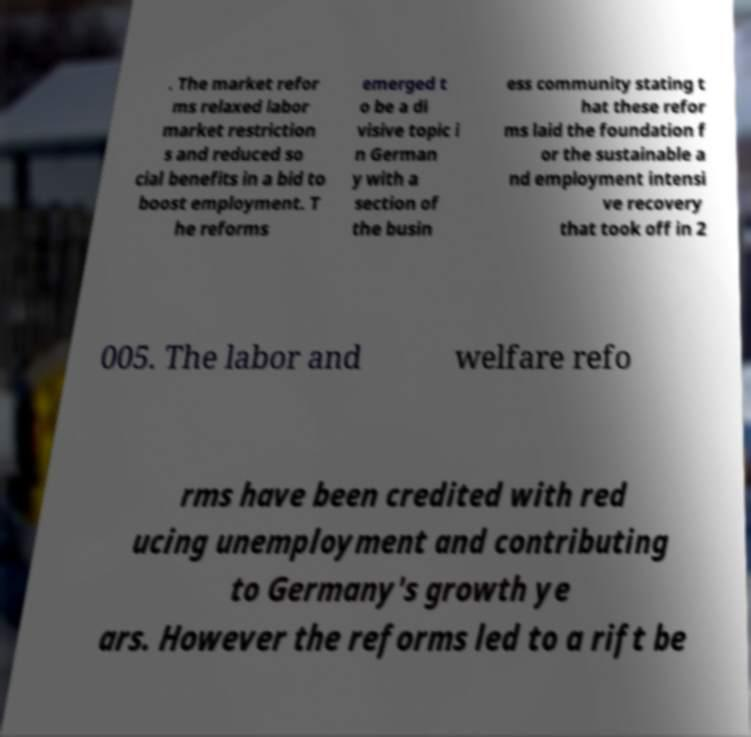Could you extract and type out the text from this image? . The market refor ms relaxed labor market restriction s and reduced so cial benefits in a bid to boost employment. T he reforms emerged t o be a di visive topic i n German y with a section of the busin ess community stating t hat these refor ms laid the foundation f or the sustainable a nd employment intensi ve recovery that took off in 2 005. The labor and welfare refo rms have been credited with red ucing unemployment and contributing to Germany's growth ye ars. However the reforms led to a rift be 